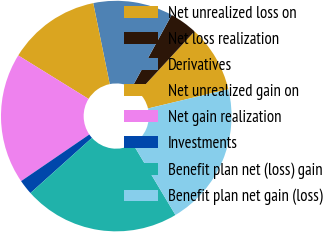<chart> <loc_0><loc_0><loc_500><loc_500><pie_chart><fcel>Net unrealized loss on<fcel>Net loss realization<fcel>Derivatives<fcel>Net unrealized gain on<fcel>Net gain realization<fcel>Investments<fcel>Benefit plan net (loss) gain<fcel>Benefit plan net gain (loss)<nl><fcel>9.39%<fcel>3.89%<fcel>11.18%<fcel>12.98%<fcel>18.36%<fcel>2.09%<fcel>21.95%<fcel>20.16%<nl></chart> 